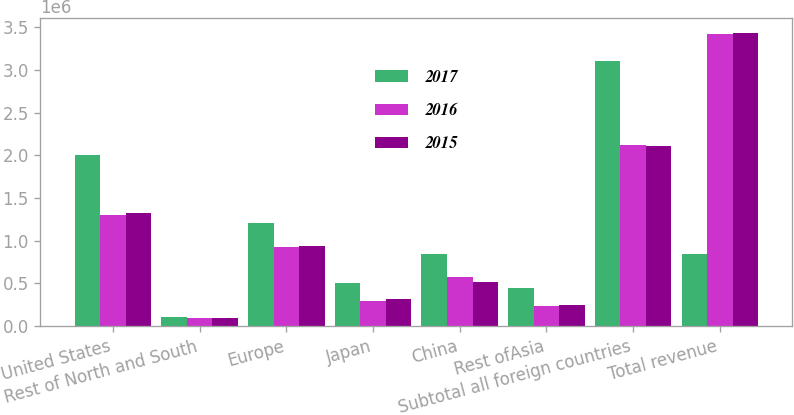Convert chart. <chart><loc_0><loc_0><loc_500><loc_500><stacked_bar_chart><ecel><fcel>United States<fcel>Rest of North and South<fcel>Europe<fcel>Japan<fcel>China<fcel>Rest ofAsia<fcel>Subtotal all foreign countries<fcel>Total revenue<nl><fcel>2017<fcel>1.99904e+06<fcel>103077<fcel>1.21144e+06<fcel>506114<fcel>842532<fcel>445304<fcel>3.10846e+06<fcel>842532<nl><fcel>2016<fcel>1.29963e+06<fcel>95957<fcel>924849<fcel>291649<fcel>575690<fcel>233635<fcel>2.12178e+06<fcel>3.42141e+06<nl><fcel>2015<fcel>1.32528e+06<fcel>97189<fcel>939230<fcel>319569<fcel>511365<fcel>242460<fcel>2.10981e+06<fcel>3.43509e+06<nl></chart> 